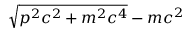<formula> <loc_0><loc_0><loc_500><loc_500>\sqrt { p ^ { 2 } c ^ { 2 } + m ^ { 2 } c ^ { 4 } } - m c ^ { 2 }</formula> 